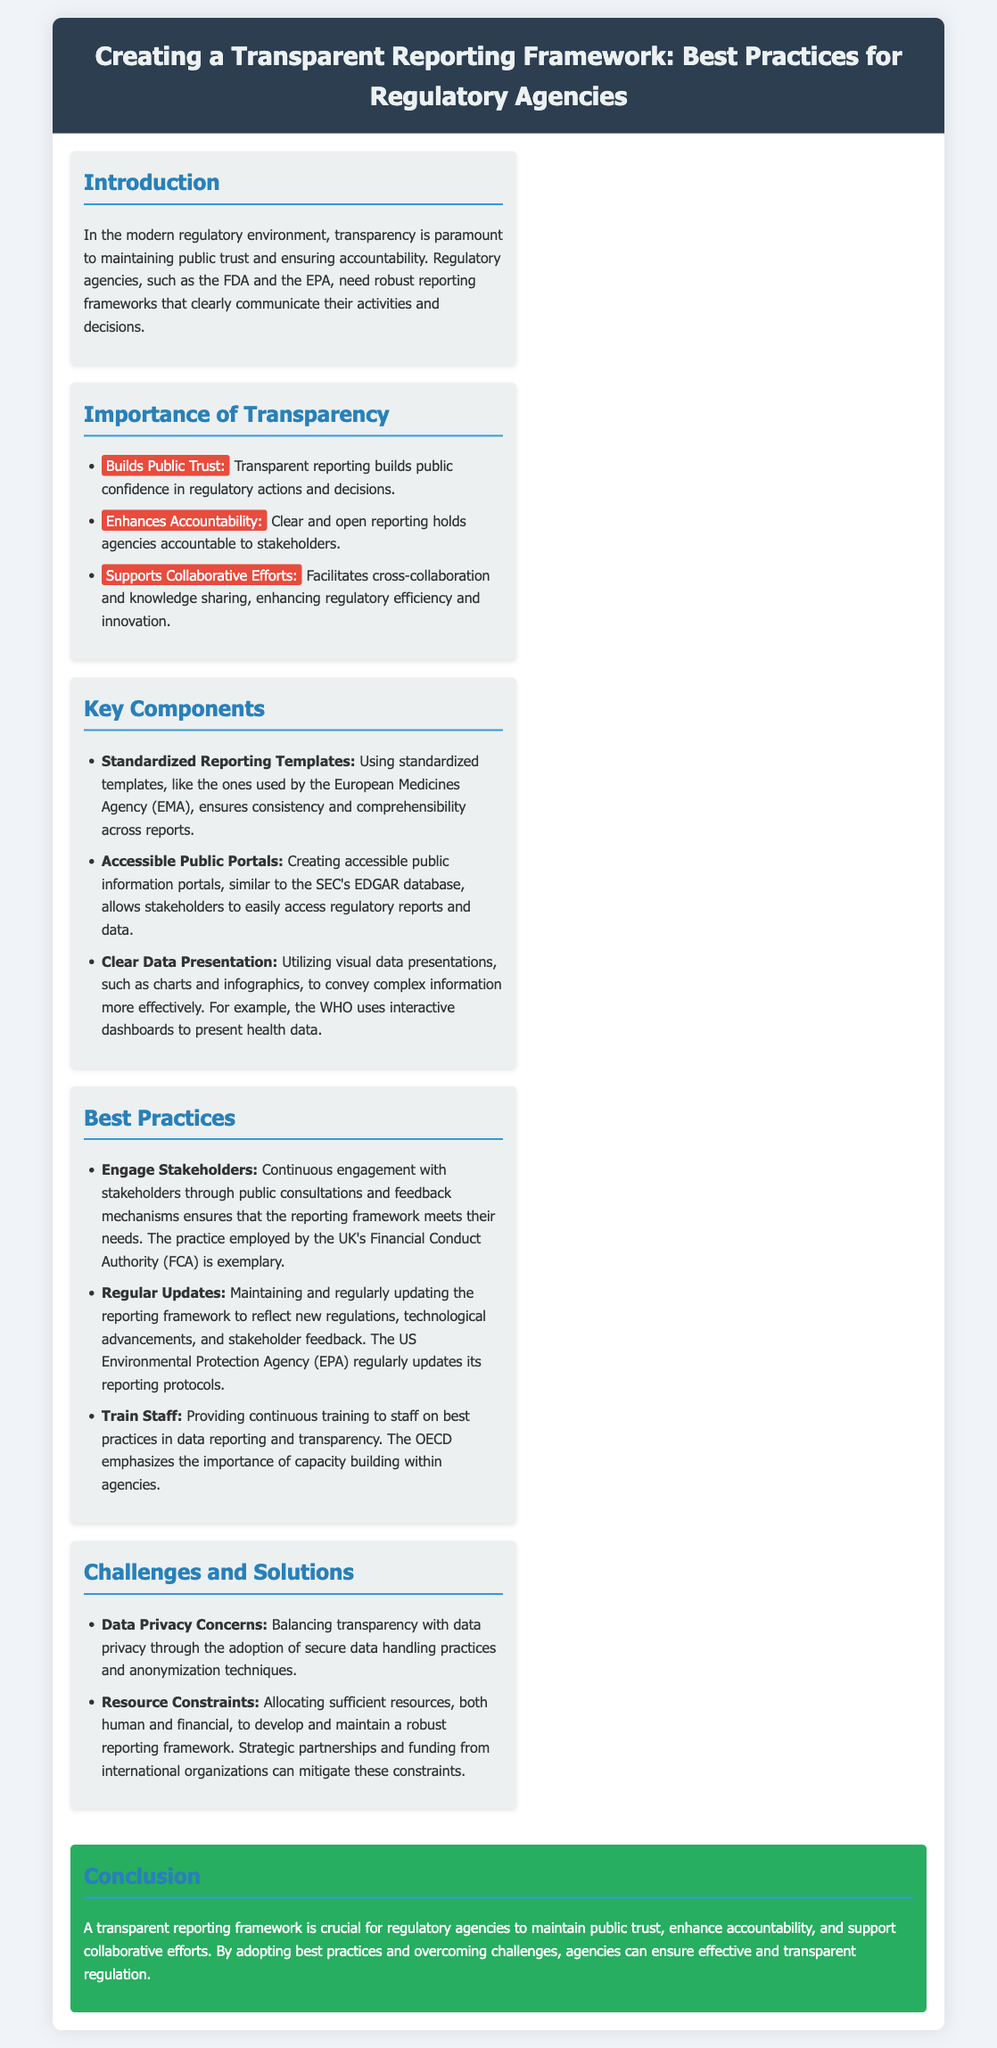What is the main title of the presentation? The main title is stated at the header and summarizes the document's focus on regulatory practices.
Answer: Creating a Transparent Reporting Framework: Best Practices for Regulatory Agencies What is one key reason for the importance of transparency? The document lists reasons for transparency, highlighting its impact on public trust.
Answer: Builds Public Trust Which agency's practices are referenced regarding standardized reporting templates? The document mentions specific agencies and their best practices in reporting.
Answer: European Medicines Agency (EMA) What does the document suggest to support collaborative efforts? The document outlines how transparency can facilitate regulatory processes and stakeholder engagements.
Answer: Supports Collaborative Efforts What type of data presentation does the document recommend? The suggestion involves utilizing specific techniques to enhance clarity in reports.
Answer: Visual data presentations What is one challenge mentioned in the document regarding transparency? The document identifies potential issues that may arise in achieving transparency.
Answer: Data Privacy Concerns How often should the reporting framework be updated? The document emphasizes the need for regularity in maintaining the framework's relevance.
Answer: Regularly What does the OECD emphasize in terms of staff training? The document highlights the importance of continuous improvement through training among staff.
Answer: Capacity building What should agencies ensure when engaging with stakeholders? The document discusses methods of interacting with stakeholders effectively for better frameworks.
Answer: Continuous engagement 